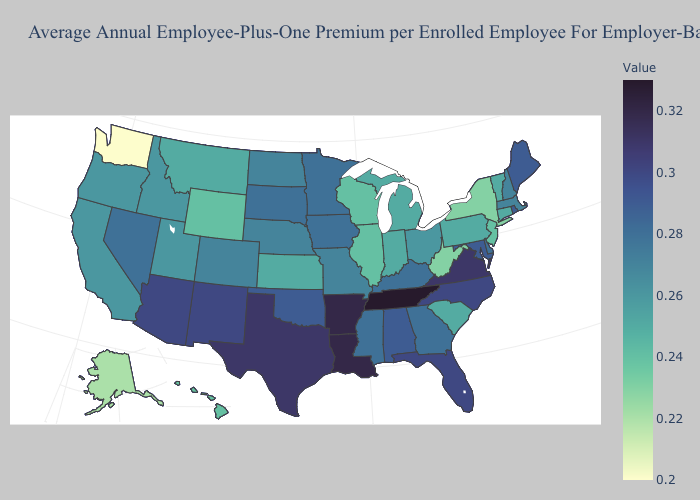Which states have the lowest value in the West?
Answer briefly. Washington. Does New Mexico have the highest value in the West?
Write a very short answer. Yes. Does Illinois have the lowest value in the MidWest?
Quick response, please. Yes. Among the states that border Texas , does Oklahoma have the highest value?
Write a very short answer. No. 